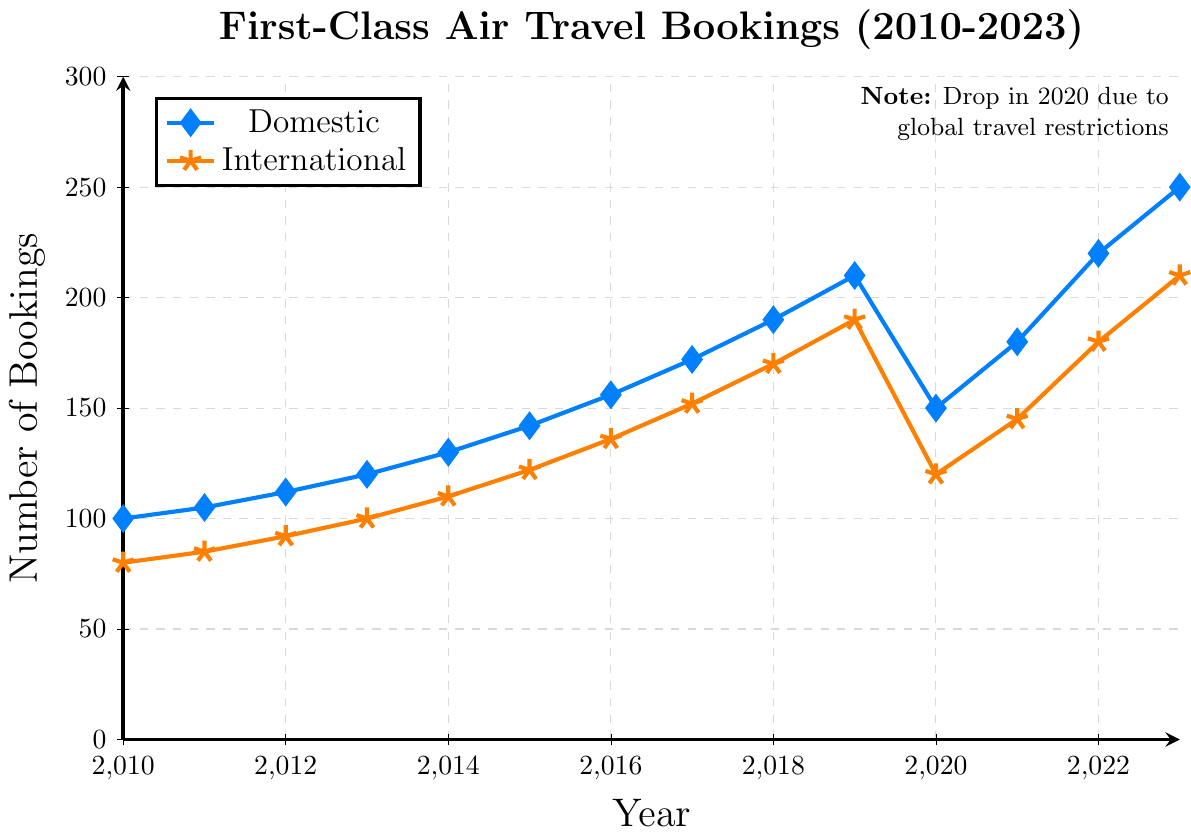What's the highest number of domestic first-class bookings recorded, and in which year did it occur? By examining the topmost point of the line representing domestic bookings, we see that the highest value reached was 250 in the year 2023.
Answer: 250 (2023) How much did international first-class bookings increase from 2010 to 2023? The value for international bookings in 2010 is 80, and in 2023 it is 210. The increase is 210 - 80 = 130.
Answer: 130 Which year shows the largest drop in domestic first-class bookings and what was the magnitude of the drop? By identifying the sharpest decline in the domestic line, we can see that the largest drop is between 2019 and 2020. The values are 210 in 2019 and 150 in 2020, so the drop is 210 - 150 = 60.
Answer: 2020, 60 In which year did international bookings first exceed 150? The year to first check where the international line crosses the 150 mark is 2017, where the bookings value is 152.
Answer: 2017 Compare domestic and international bookings in 2018. Which was higher and by how much? In 2018 domestic bookings were 190 and international bookings were 170. The difference is 190 - 170 = 20, with domestic bookings being higher.
Answer: Domestic, 20 What's the average number of domestic first-class bookings between 2010 and 2023? Adding up all the domestic values and dividing by the number of years, we get (100+105+112+120+130+142+156+172+190+210+150+180+220+250) / 14 = 1906 / 14 = 136.14.
Answer: 136.14 Was the growth in international bookings from 2011 to 2013 higher than the growth in domestic bookings for the same period? Calculating the growth for each:
International: 100 - 85 = 15
Domestic: 120 - 105 = 15
The growth for both is equal to 15.
Answer: No, they were equal What is the total number of first-class bookings (both domestic and international) in 2023? Summing the 2023 values for both domestic and international: 250 + 210 = 460.
Answer: 460 